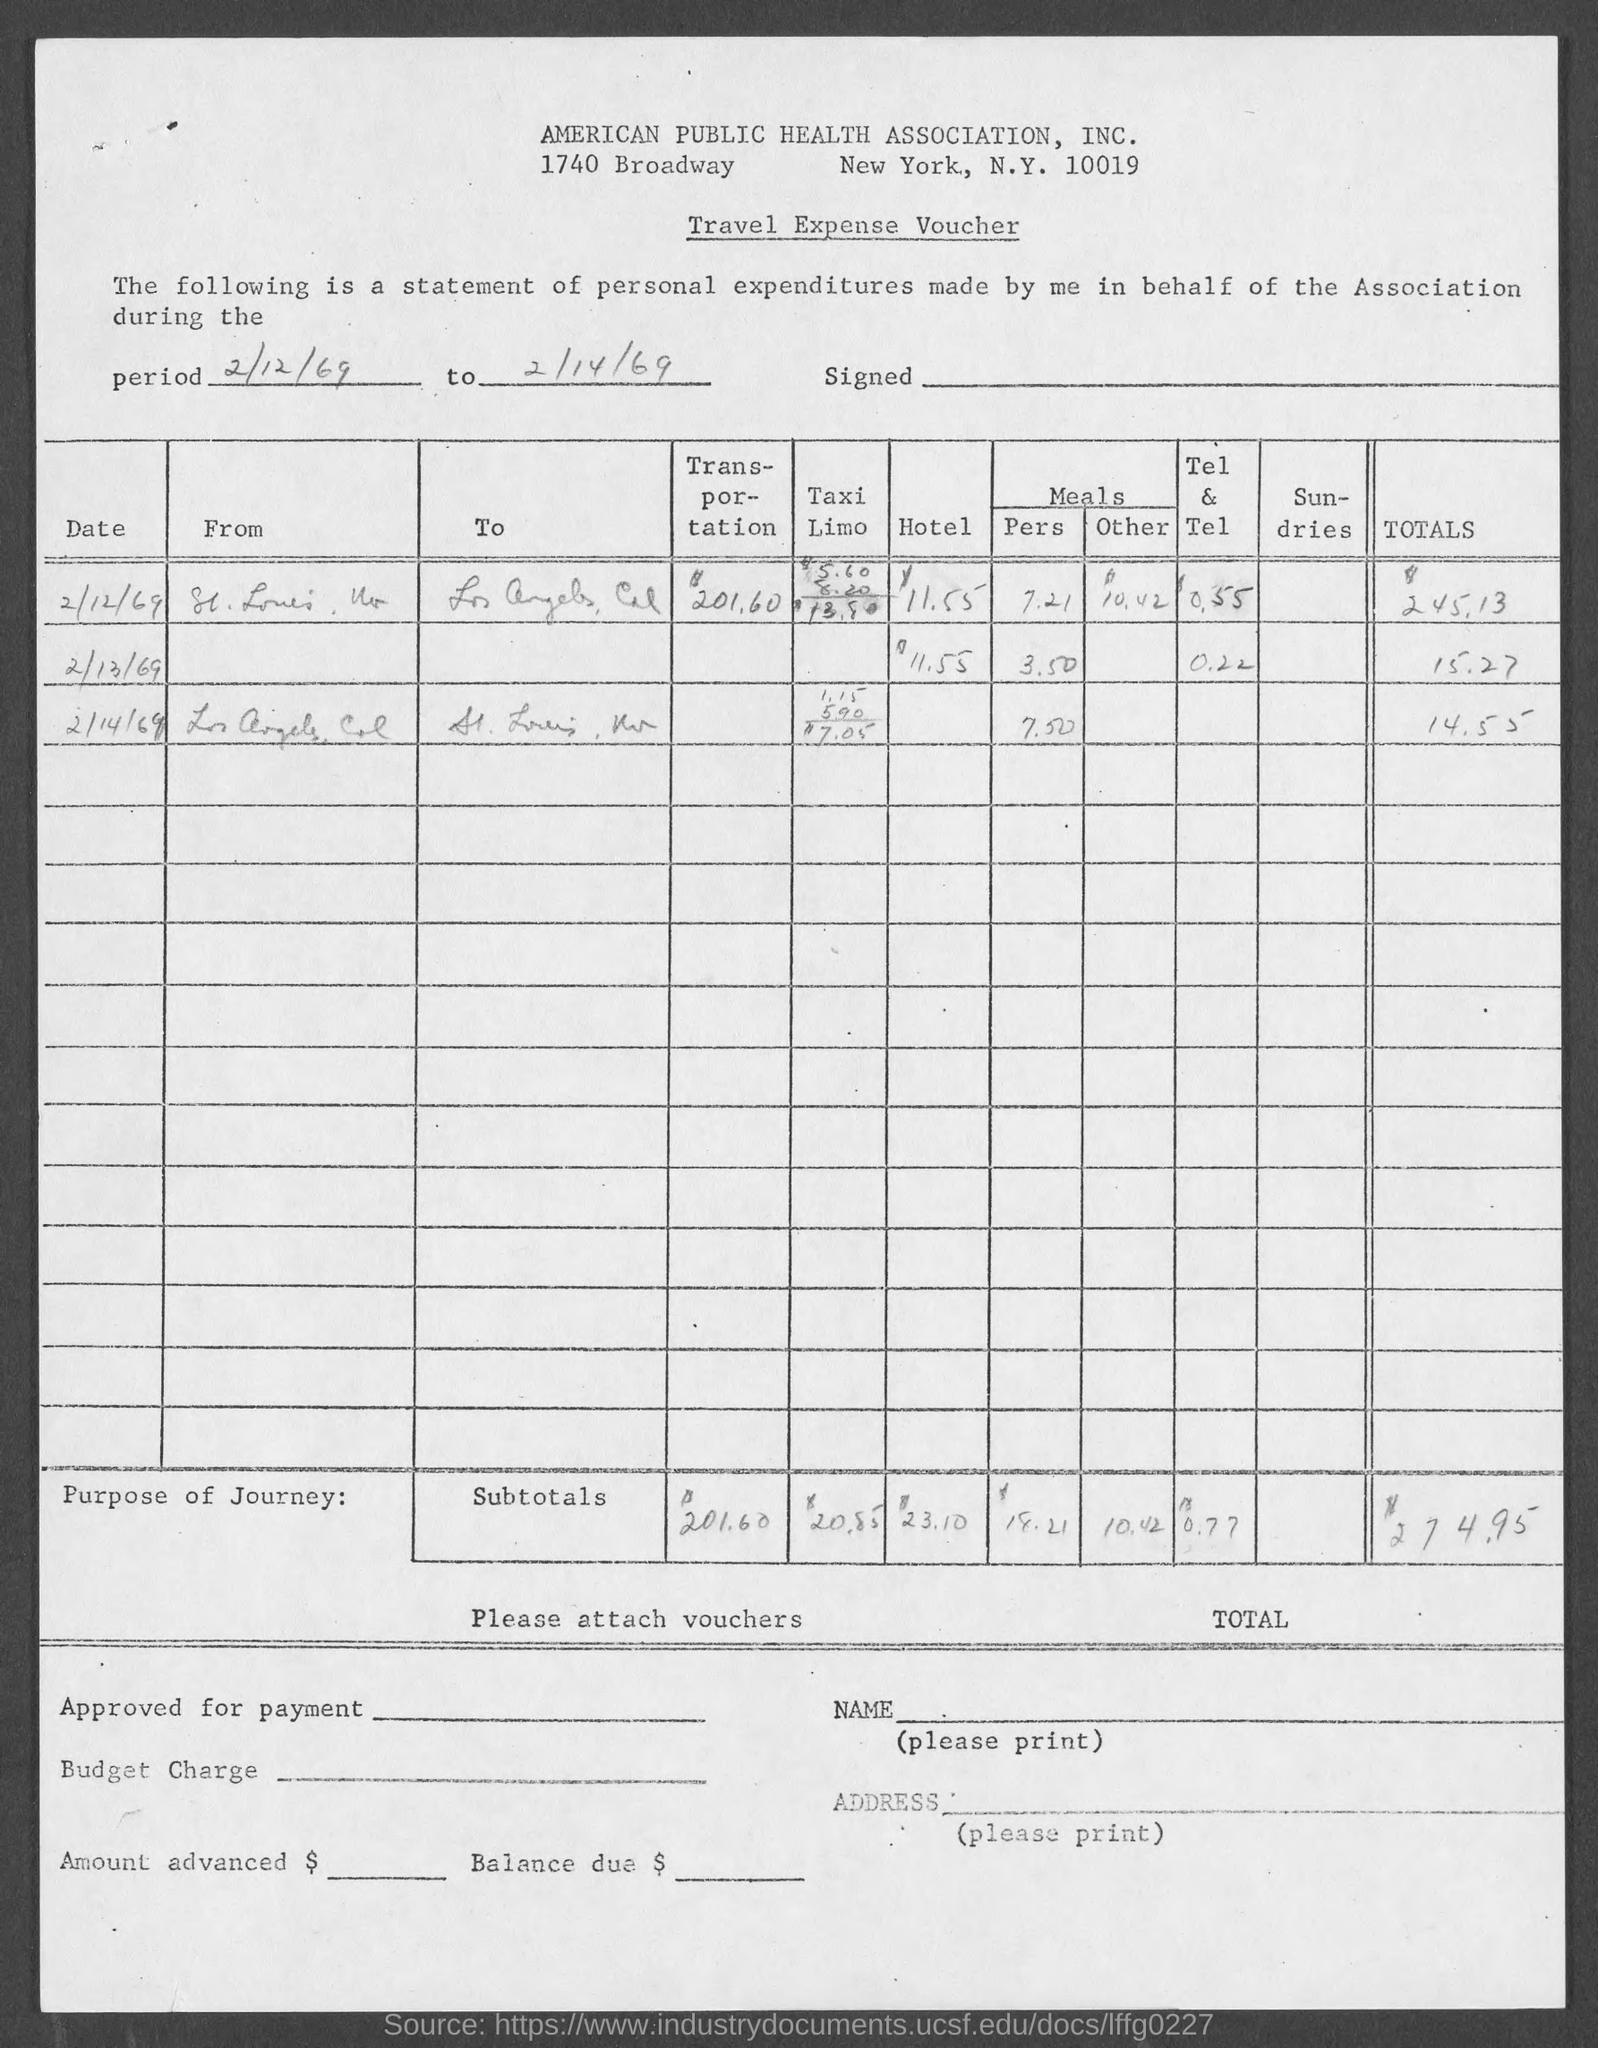In which city is american public health association, inc. at?
Keep it short and to the point. New York. 